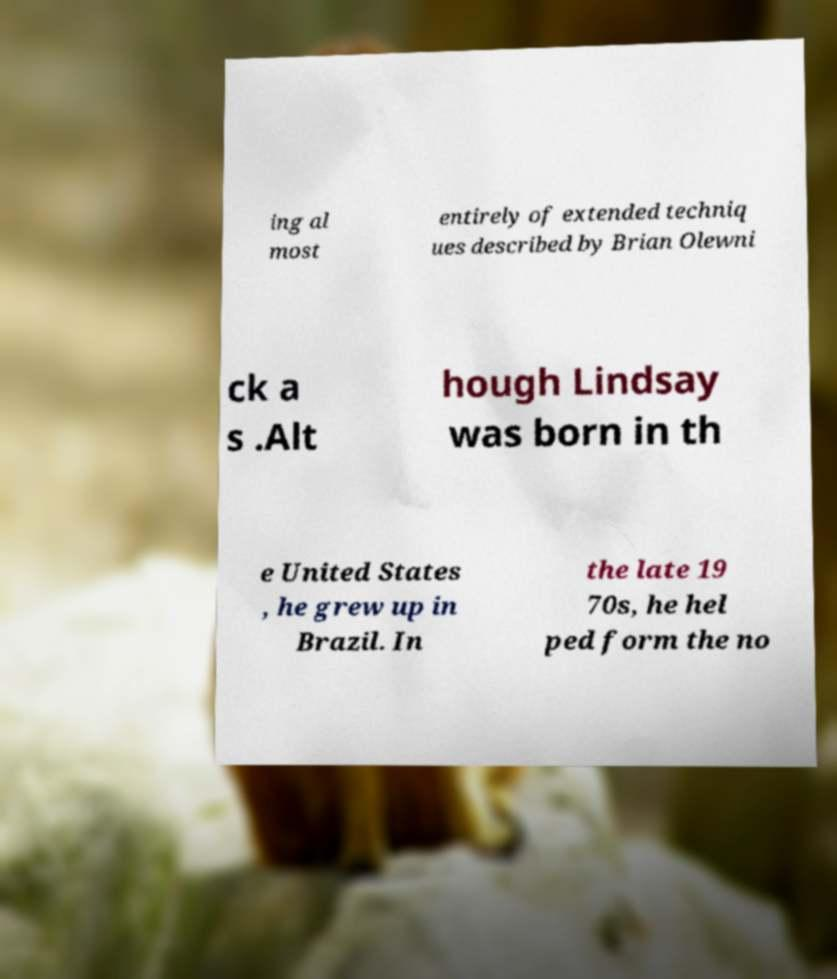Can you read and provide the text displayed in the image?This photo seems to have some interesting text. Can you extract and type it out for me? ing al most entirely of extended techniq ues described by Brian Olewni ck a s .Alt hough Lindsay was born in th e United States , he grew up in Brazil. In the late 19 70s, he hel ped form the no 